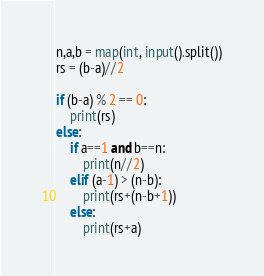<code> <loc_0><loc_0><loc_500><loc_500><_Python_>n,a,b = map(int, input().split())
rs = (b-a)//2

if (b-a) % 2 == 0:
    print(rs)
else:
    if a==1 and b==n:
        print(n//2)
    elif (a-1) > (n-b):
        print(rs+(n-b+1))
    else:
        print(rs+a)</code> 